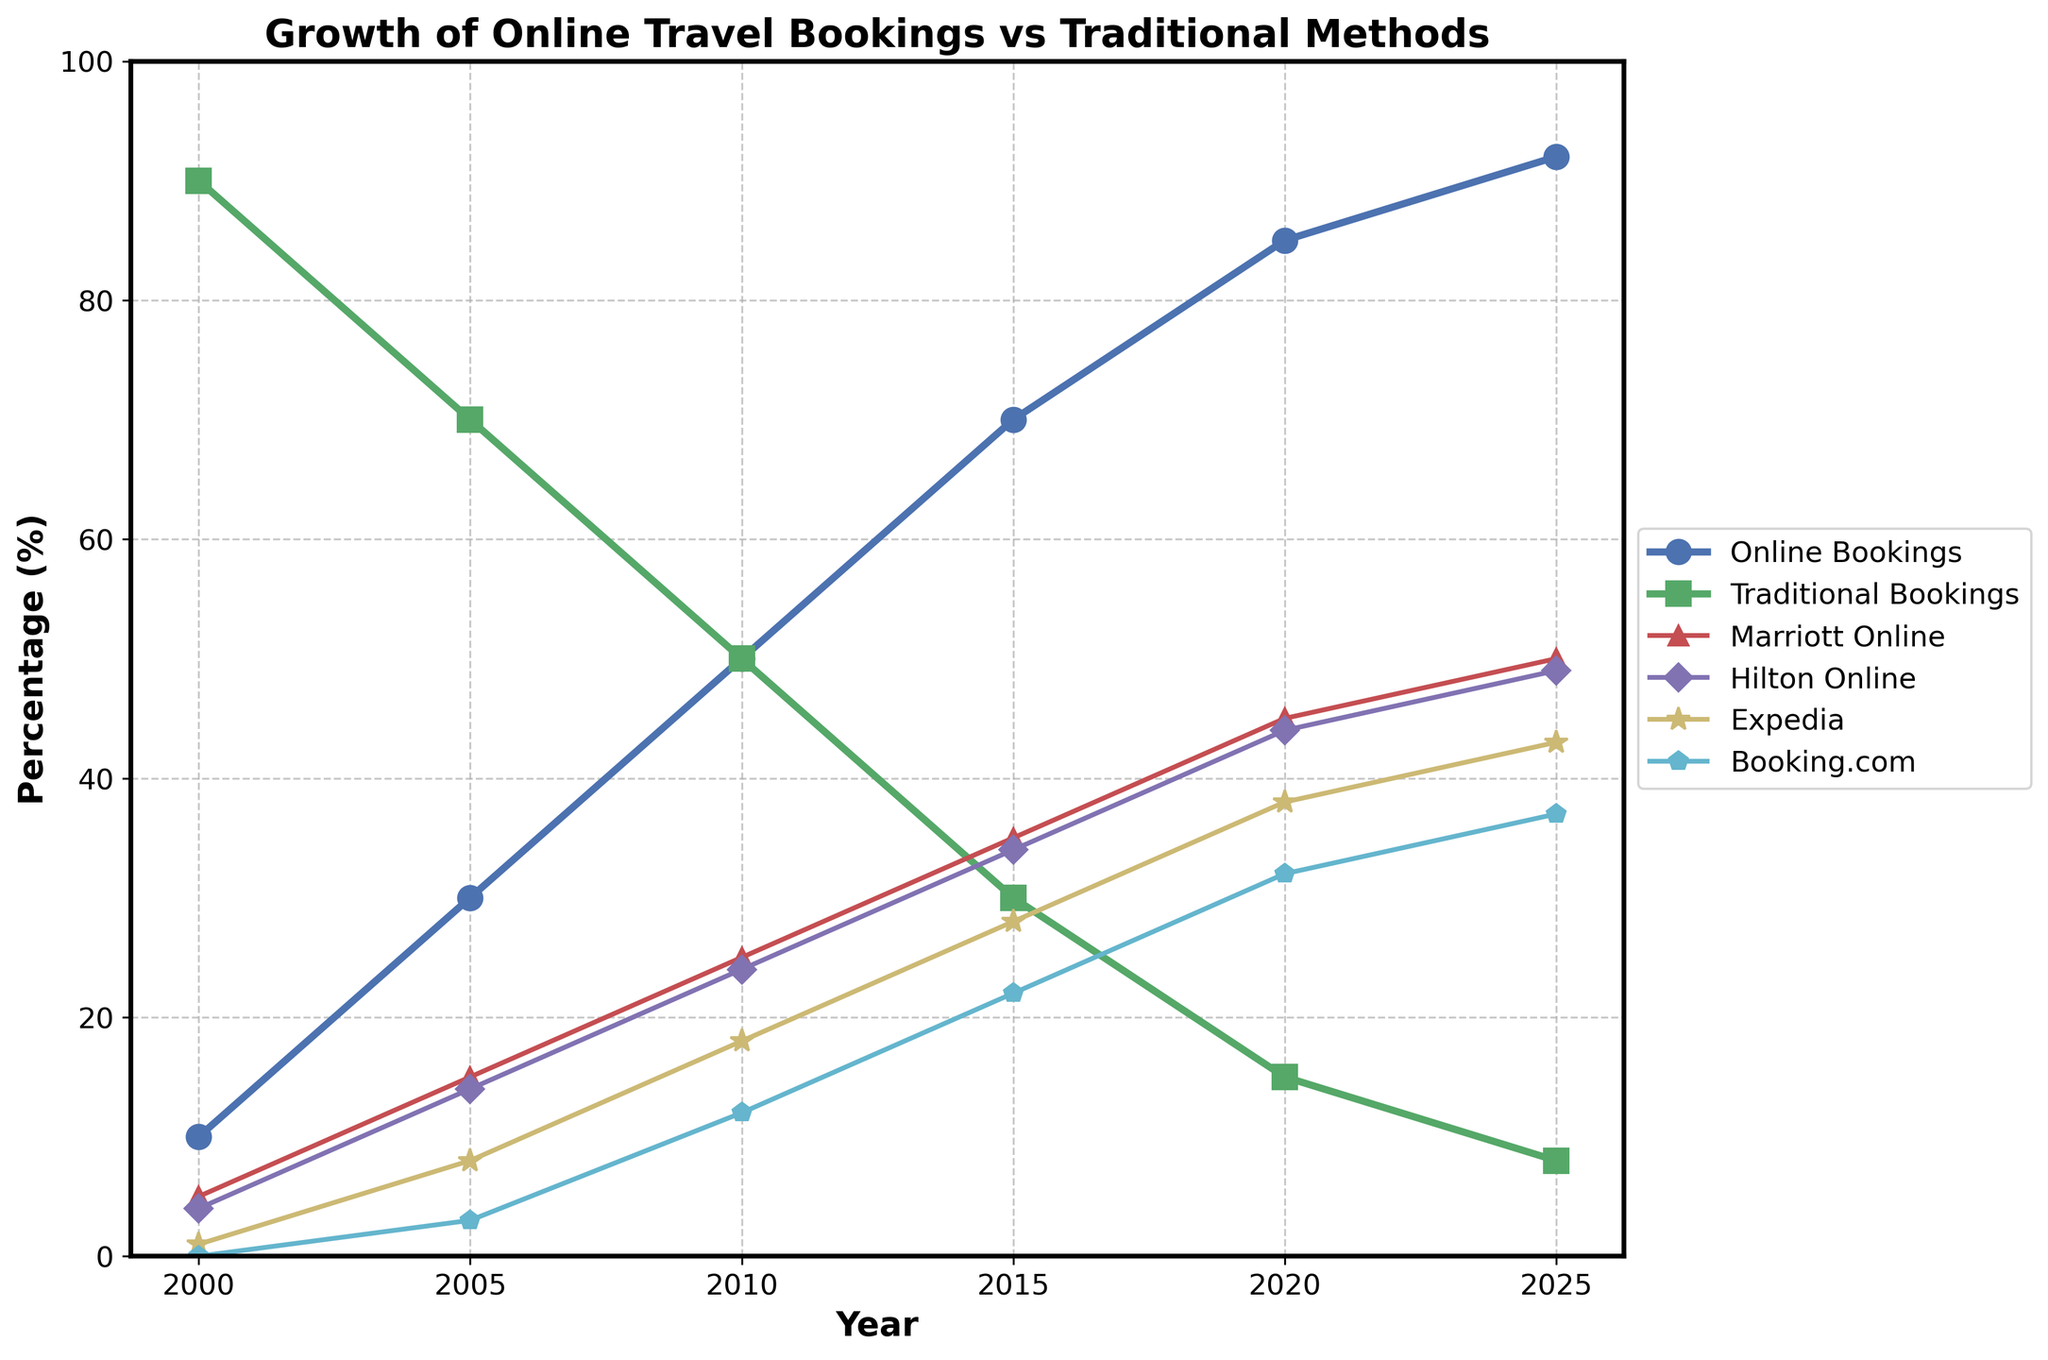Which year saw the highest percentage of traditional bookings? The highest percentage of traditional bookings is seen in the earlier years of the data. By checking the values for traditional bookings from 2000 to 2025, the highest percentage is 90% in the year 2000.
Answer: 2000 In 2020, what was the difference in percentage between online bookings and traditional bookings? In 2020, the percentage of online bookings was 85% and traditional bookings was 15%. The difference is calculated by subtracting the percentage of traditional bookings from online bookings: 85% - 15% = 70%.
Answer: 70% How did Marriott's online bookings trend from 2005 to 2025? To observe the trend for Marriott online bookings, look at the percentages for the years 2005, 2010, 2015, 2020, and 2025: 15%, 25%, 35%, 45%, and 50%, respectively. Marriott's online bookings increased consistently over these years.
Answer: Increasing Which company showed the most significant increase in online bookings from 2000 to 2020? By comparing the online booking percentages from 2000 to 2020 for Marriott, Hilton, Expedia, and Booking.com, we see the increments: Marriott (5% to 45%), Hilton (4% to 44%), Expedia (1% to 38%), and Booking.com (0% to 32%). Hilton had the most significant increase from 4% to 44%, an increase of 40%.
Answer: Hilton What was the average percentage of online bookings for Expedia over the recorded years? The percentages of online bookings for Expedia over the recorded years are 1%, 8%, 18%, 28%, 38%, and 43%. To get the average, sum these values (1 + 8 + 18 + 28 + 38 + 43 = 136) and divide by the number of years: 136/6 ≈ 22.67%.
Answer: ≈ 22.67% Did traditional bookings ever drop below 10%? To determine if traditional bookings ever dropped below 10%, check the percentages for each year from 2000 to 2025. The lowest percentage of traditional bookings is 8% in 2025, which is below 10%.
Answer: Yes What is the combined percentage of online bookings for Marriott and Hilton in 2015? The percentage of online bookings for Marriott in 2015 is 35% and for Hilton is 34%. Adding these two percentages gives the combined percentage: 35% + 34% = 69%.
Answer: 69% By how much did Booking.com's online bookings increase from 2015 to 2025? The online bookings for Booking.com in 2015 were 22% and in 2025 were 37%. To find the increase, subtract the 2015 value from the 2025 value: 37% - 22% = 15%.
Answer: 15% Which year marks the point where online bookings surpassed traditional bookings in terms of percentage? By examining the crossing point on the line chart, we see that online bookings surpassed traditional bookings around the year 2010, where both were at 50%.
Answer: 2010 